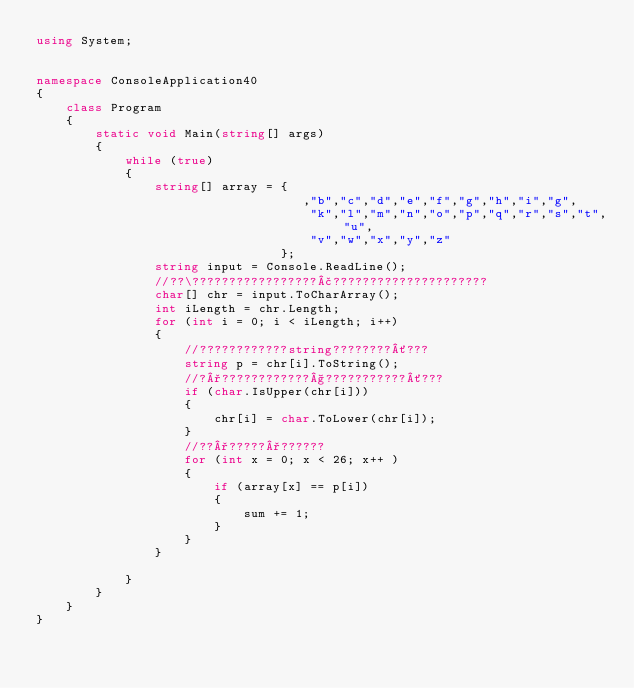<code> <loc_0><loc_0><loc_500><loc_500><_C#_>using System;


namespace ConsoleApplication40
{
    class Program
    {
        static void Main(string[] args)
        {
            while (true)
            {
                string[] array = {
                                    ,"b","c","d","e","f","g","h","i","g",
                                     "k","l","m","n","o","p","q","r","s","t","u",
                                     "v","w","x","y","z"
                                 };
                string input = Console.ReadLine();
                //??\?????????????????£?????????????????????
                char[] chr = input.ToCharArray();
                int iLength = chr.Length;
                for (int i = 0; i < iLength; i++)
                {
                    //????????????string????????´???
                    string p = chr[i].ToString();
                    //?°????????????§???????????´???
                    if (char.IsUpper(chr[i]))
                    {
                        chr[i] = char.ToLower(chr[i]);
                    }
                    //??°?????°??????
                    for (int x = 0; x < 26; x++ )
                    {
                        if (array[x] == p[i])
                        {
                            sum += 1;
                        }
                    }
                }
 
            }
        }
    }
}</code> 